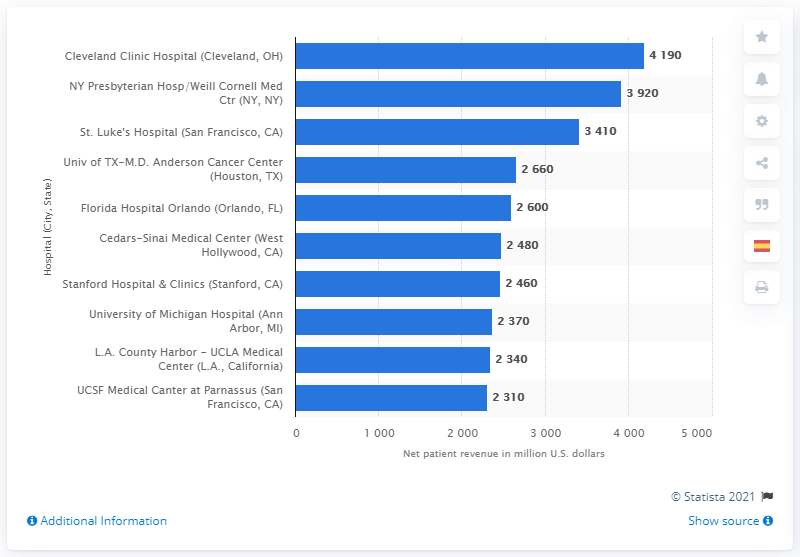List a handful of essential elements in this visual. The Cleveland Clinic Hospital generated approximately $4,190 in net patient revenue in 2014. 